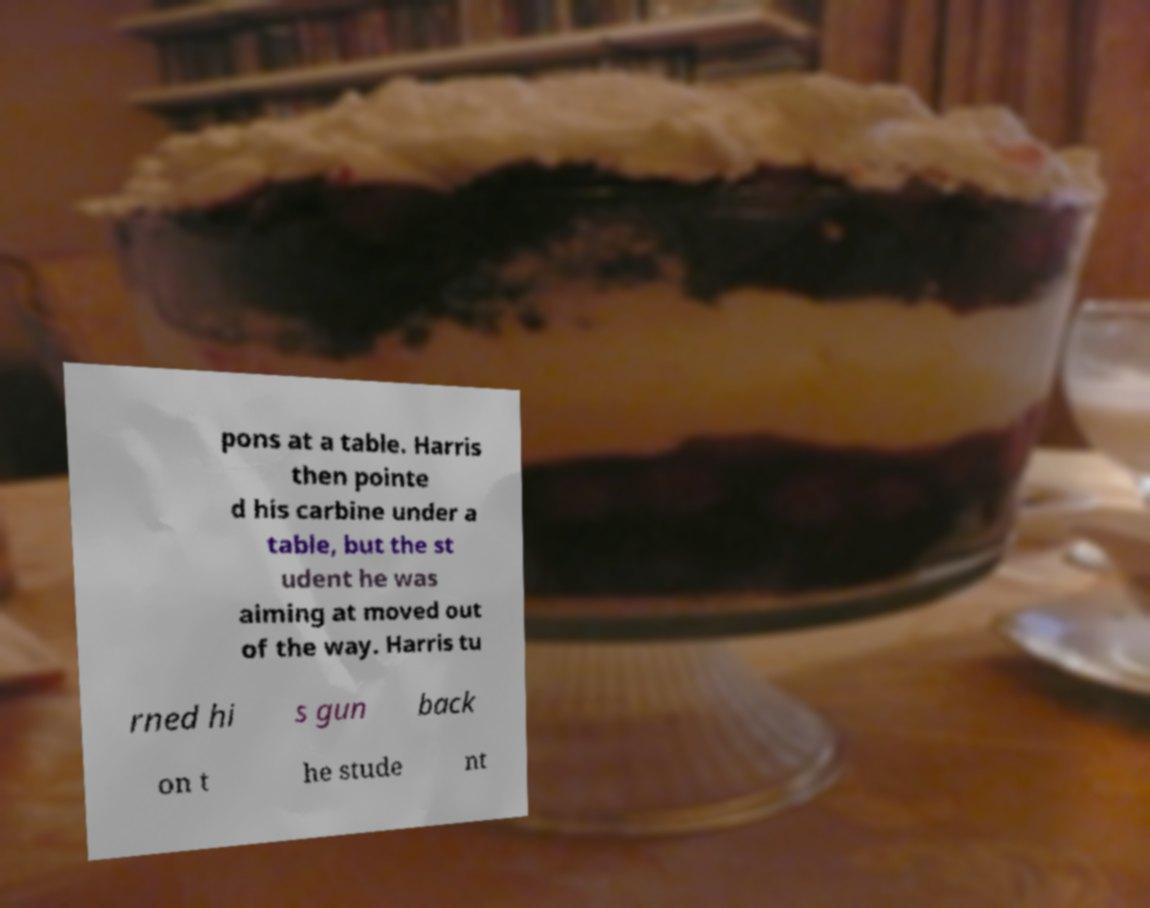What messages or text are displayed in this image? I need them in a readable, typed format. pons at a table. Harris then pointe d his carbine under a table, but the st udent he was aiming at moved out of the way. Harris tu rned hi s gun back on t he stude nt 